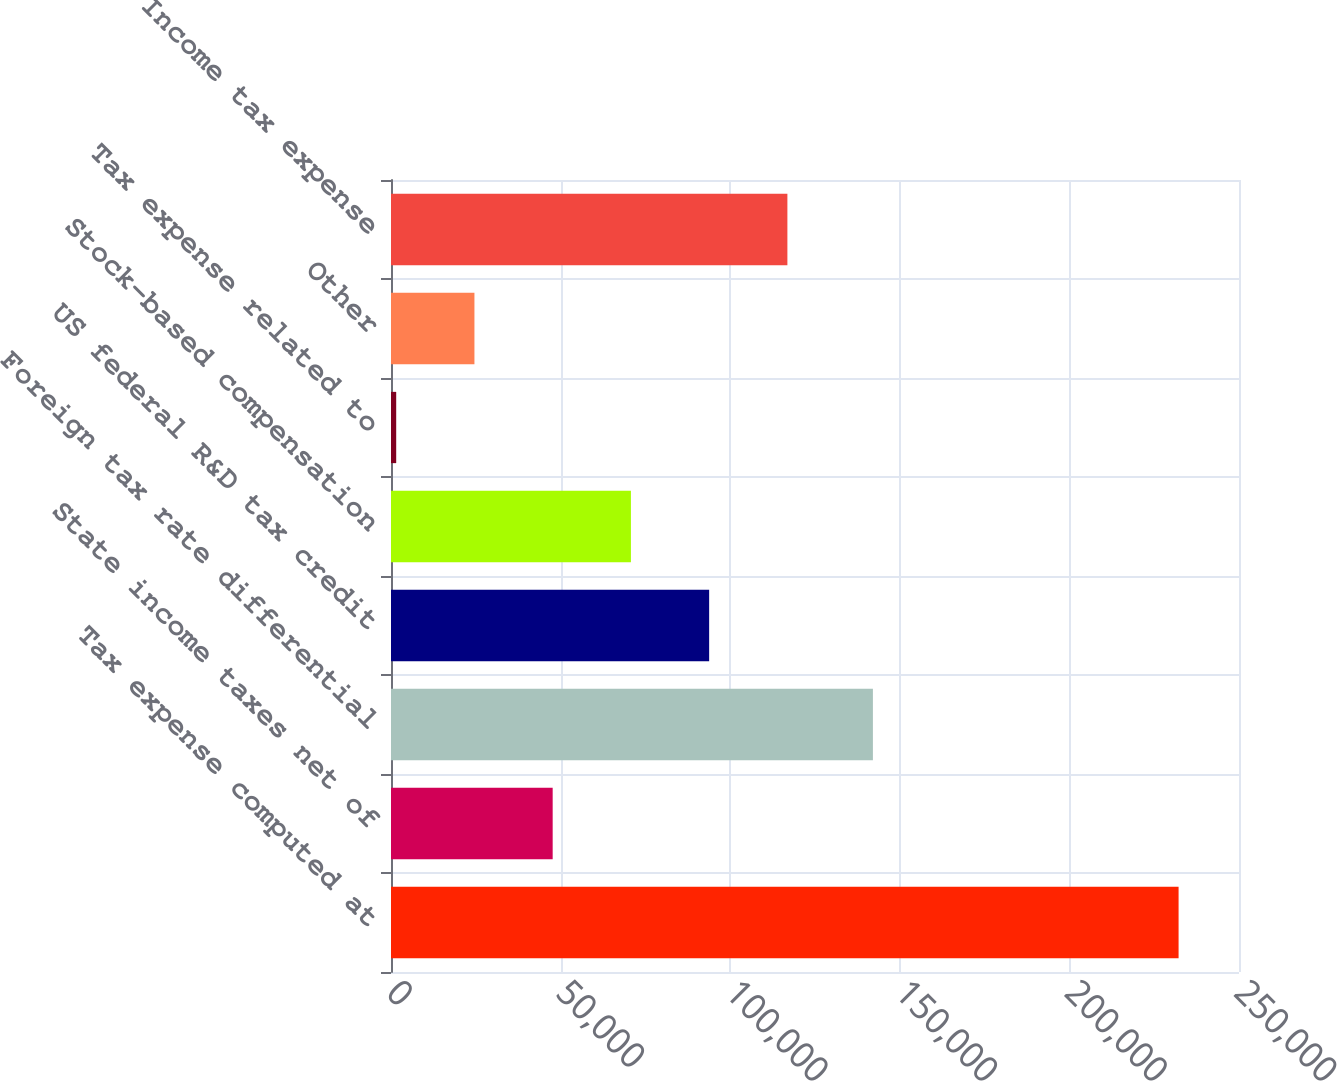<chart> <loc_0><loc_0><loc_500><loc_500><bar_chart><fcel>Tax expense computed at<fcel>State income taxes net of<fcel>Foreign tax rate differential<fcel>US federal R&D tax credit<fcel>Stock-based compensation<fcel>Tax expense related to<fcel>Other<fcel>Income tax expense<nl><fcel>232189<fcel>47664.2<fcel>142071<fcel>93795.4<fcel>70729.8<fcel>1533<fcel>24598.6<fcel>116861<nl></chart> 